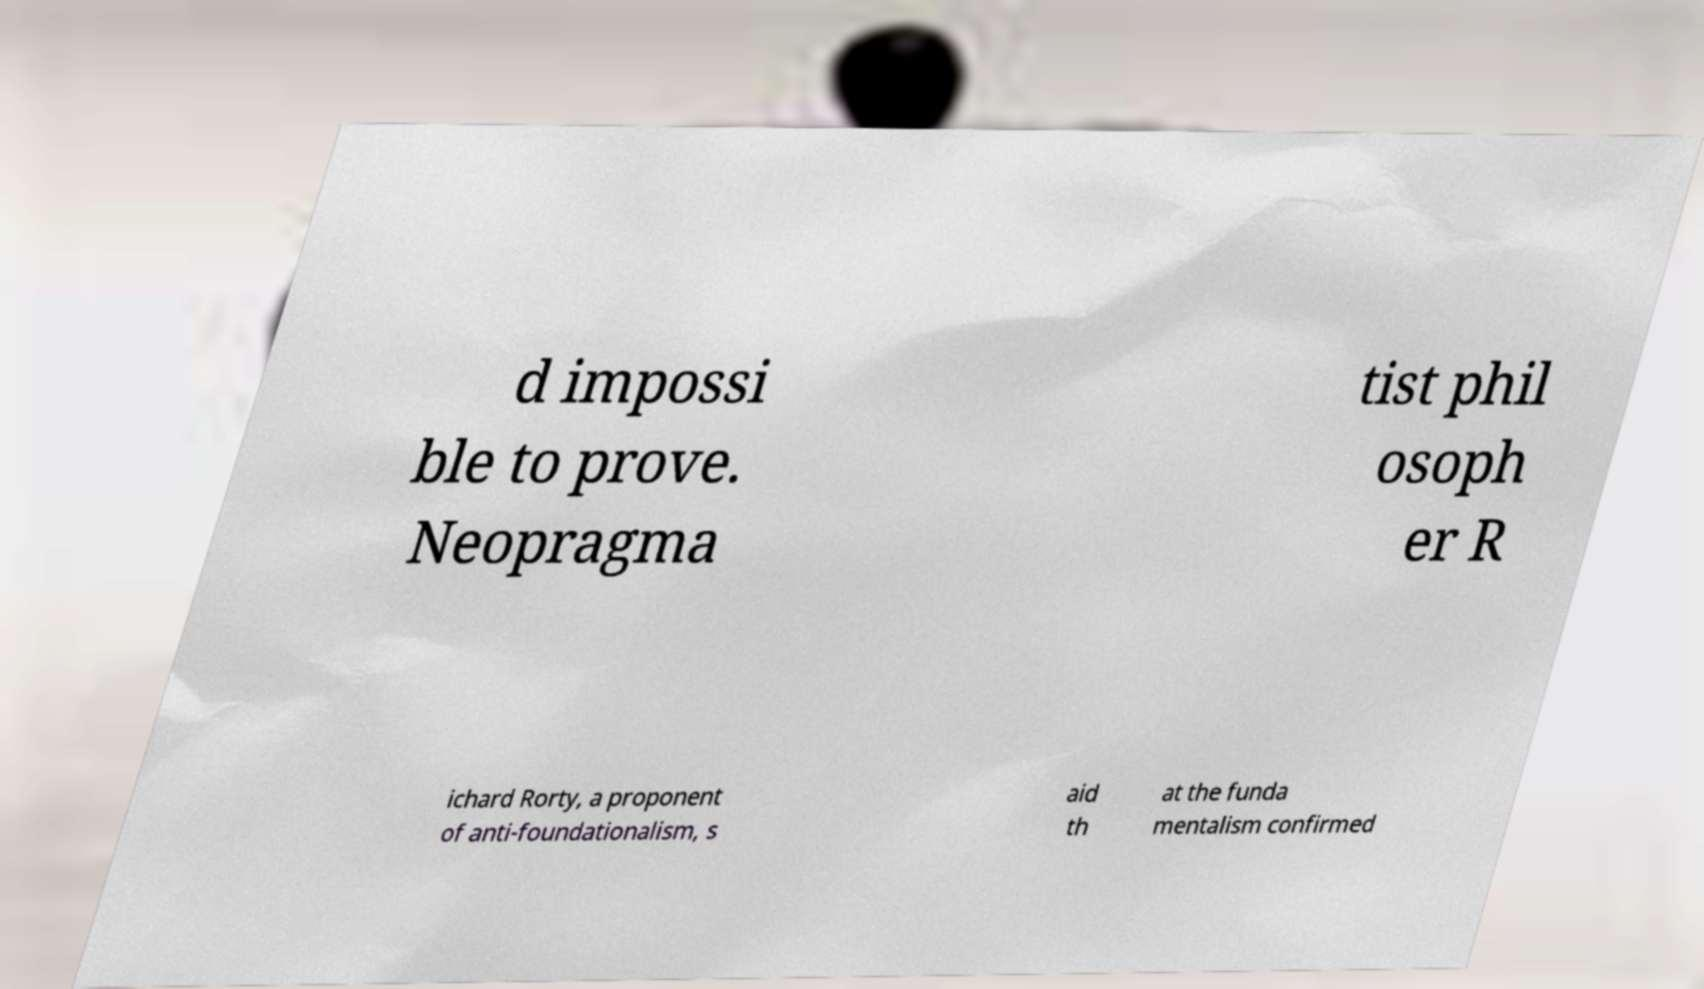Please read and relay the text visible in this image. What does it say? d impossi ble to prove. Neopragma tist phil osoph er R ichard Rorty, a proponent of anti-foundationalism, s aid th at the funda mentalism confirmed 